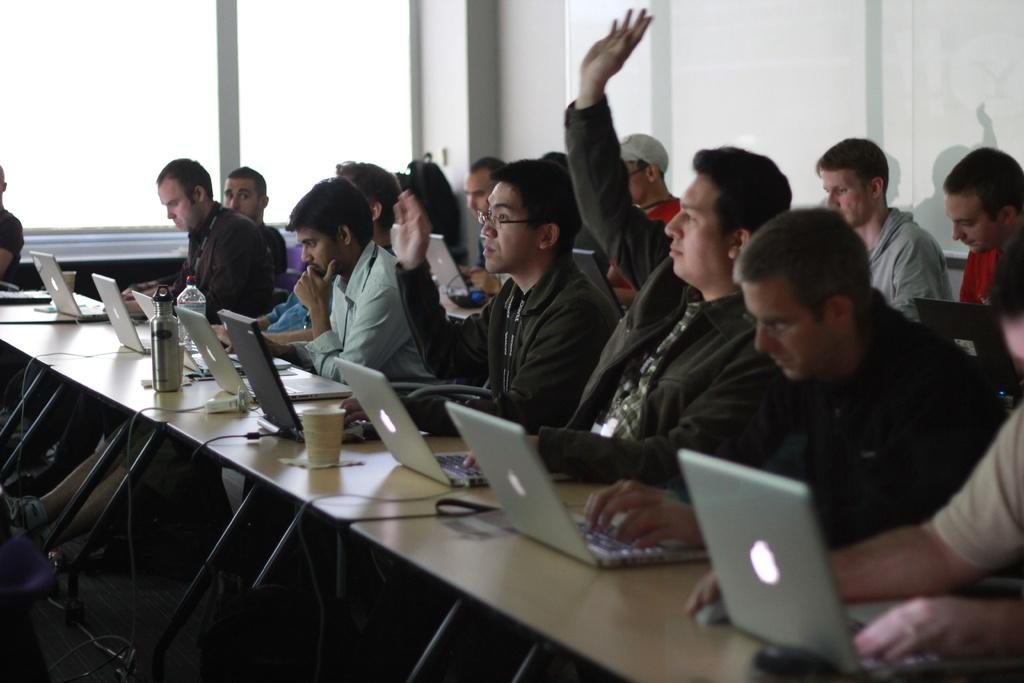What are the people in the image doing? People are sitting in the image. Can you describe the action of one of the individuals? A person is raising their hand. What objects are present on the tables in the image? There are laptops, glasses, and bottles on the tables. What type of windows can be seen in the image? There are glass windows at the back of the room. What type of error message is displayed on the table in the image? There is no error message present on the table in the image. Can you tell me the name of the governor who is sitting at the table in the image? There is no governor present in the image. 